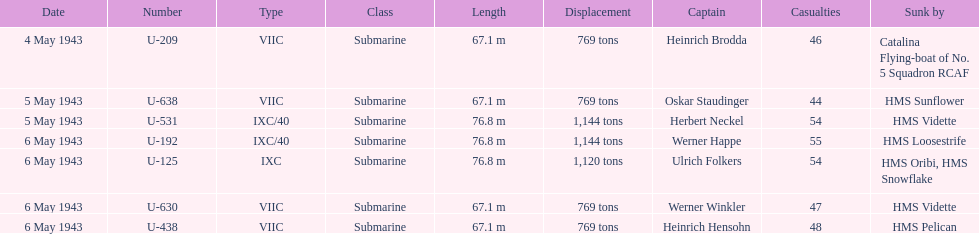How many captains are listed? 7. 